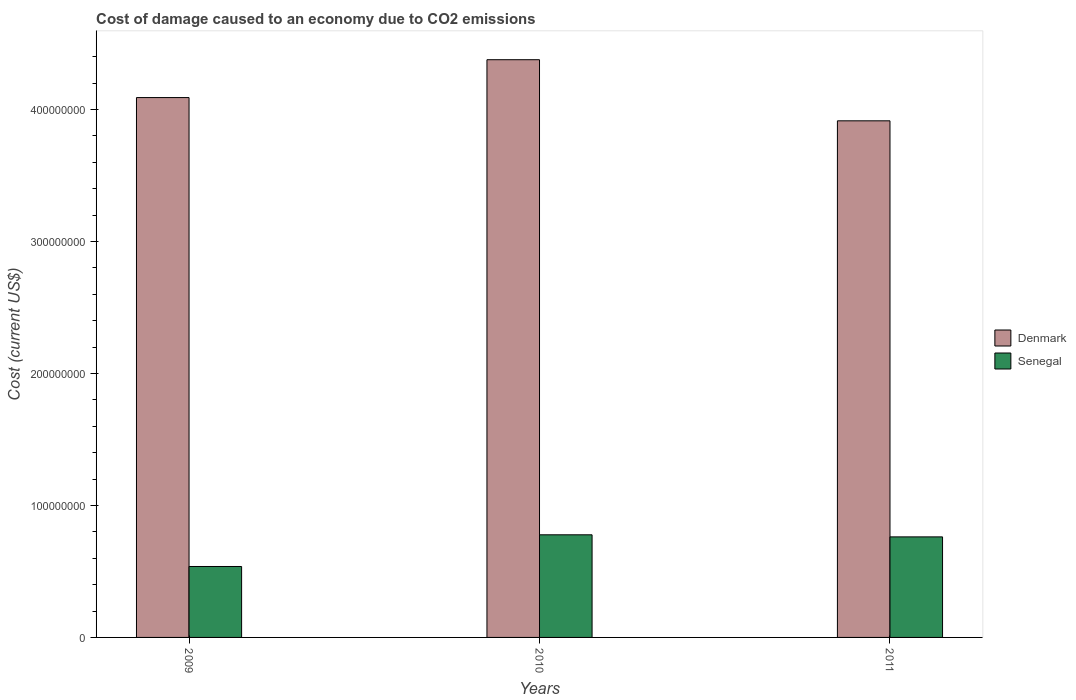How many groups of bars are there?
Your answer should be compact. 3. How many bars are there on the 2nd tick from the left?
Keep it short and to the point. 2. What is the cost of damage caused due to CO2 emissisons in Denmark in 2011?
Ensure brevity in your answer.  3.91e+08. Across all years, what is the maximum cost of damage caused due to CO2 emissisons in Denmark?
Your answer should be compact. 4.38e+08. Across all years, what is the minimum cost of damage caused due to CO2 emissisons in Senegal?
Provide a short and direct response. 5.37e+07. In which year was the cost of damage caused due to CO2 emissisons in Senegal maximum?
Keep it short and to the point. 2010. In which year was the cost of damage caused due to CO2 emissisons in Senegal minimum?
Offer a very short reply. 2009. What is the total cost of damage caused due to CO2 emissisons in Denmark in the graph?
Your answer should be compact. 1.24e+09. What is the difference between the cost of damage caused due to CO2 emissisons in Denmark in 2009 and that in 2011?
Make the answer very short. 1.76e+07. What is the difference between the cost of damage caused due to CO2 emissisons in Denmark in 2010 and the cost of damage caused due to CO2 emissisons in Senegal in 2009?
Ensure brevity in your answer.  3.84e+08. What is the average cost of damage caused due to CO2 emissisons in Denmark per year?
Your answer should be very brief. 4.13e+08. In the year 2011, what is the difference between the cost of damage caused due to CO2 emissisons in Denmark and cost of damage caused due to CO2 emissisons in Senegal?
Make the answer very short. 3.15e+08. What is the ratio of the cost of damage caused due to CO2 emissisons in Denmark in 2009 to that in 2011?
Your answer should be compact. 1.05. What is the difference between the highest and the second highest cost of damage caused due to CO2 emissisons in Senegal?
Keep it short and to the point. 1.58e+06. What is the difference between the highest and the lowest cost of damage caused due to CO2 emissisons in Denmark?
Give a very brief answer. 4.63e+07. What does the 1st bar from the left in 2010 represents?
Offer a very short reply. Denmark. How many bars are there?
Keep it short and to the point. 6. What is the difference between two consecutive major ticks on the Y-axis?
Give a very brief answer. 1.00e+08. Does the graph contain grids?
Your answer should be very brief. No. How many legend labels are there?
Give a very brief answer. 2. What is the title of the graph?
Provide a short and direct response. Cost of damage caused to an economy due to CO2 emissions. Does "Saudi Arabia" appear as one of the legend labels in the graph?
Provide a succinct answer. No. What is the label or title of the X-axis?
Keep it short and to the point. Years. What is the label or title of the Y-axis?
Give a very brief answer. Cost (current US$). What is the Cost (current US$) of Denmark in 2009?
Ensure brevity in your answer.  4.09e+08. What is the Cost (current US$) of Senegal in 2009?
Your answer should be very brief. 5.37e+07. What is the Cost (current US$) in Denmark in 2010?
Your answer should be very brief. 4.38e+08. What is the Cost (current US$) in Senegal in 2010?
Your answer should be compact. 7.77e+07. What is the Cost (current US$) of Denmark in 2011?
Your answer should be very brief. 3.91e+08. What is the Cost (current US$) of Senegal in 2011?
Make the answer very short. 7.62e+07. Across all years, what is the maximum Cost (current US$) in Denmark?
Your response must be concise. 4.38e+08. Across all years, what is the maximum Cost (current US$) in Senegal?
Offer a terse response. 7.77e+07. Across all years, what is the minimum Cost (current US$) in Denmark?
Provide a short and direct response. 3.91e+08. Across all years, what is the minimum Cost (current US$) of Senegal?
Provide a succinct answer. 5.37e+07. What is the total Cost (current US$) in Denmark in the graph?
Provide a succinct answer. 1.24e+09. What is the total Cost (current US$) of Senegal in the graph?
Make the answer very short. 2.08e+08. What is the difference between the Cost (current US$) of Denmark in 2009 and that in 2010?
Your response must be concise. -2.87e+07. What is the difference between the Cost (current US$) of Senegal in 2009 and that in 2010?
Give a very brief answer. -2.40e+07. What is the difference between the Cost (current US$) of Denmark in 2009 and that in 2011?
Ensure brevity in your answer.  1.76e+07. What is the difference between the Cost (current US$) of Senegal in 2009 and that in 2011?
Make the answer very short. -2.24e+07. What is the difference between the Cost (current US$) of Denmark in 2010 and that in 2011?
Provide a short and direct response. 4.63e+07. What is the difference between the Cost (current US$) of Senegal in 2010 and that in 2011?
Ensure brevity in your answer.  1.58e+06. What is the difference between the Cost (current US$) in Denmark in 2009 and the Cost (current US$) in Senegal in 2010?
Offer a very short reply. 3.31e+08. What is the difference between the Cost (current US$) of Denmark in 2009 and the Cost (current US$) of Senegal in 2011?
Offer a terse response. 3.33e+08. What is the difference between the Cost (current US$) of Denmark in 2010 and the Cost (current US$) of Senegal in 2011?
Offer a very short reply. 3.62e+08. What is the average Cost (current US$) of Denmark per year?
Provide a short and direct response. 4.13e+08. What is the average Cost (current US$) of Senegal per year?
Provide a short and direct response. 6.92e+07. In the year 2009, what is the difference between the Cost (current US$) of Denmark and Cost (current US$) of Senegal?
Provide a succinct answer. 3.55e+08. In the year 2010, what is the difference between the Cost (current US$) in Denmark and Cost (current US$) in Senegal?
Make the answer very short. 3.60e+08. In the year 2011, what is the difference between the Cost (current US$) in Denmark and Cost (current US$) in Senegal?
Your response must be concise. 3.15e+08. What is the ratio of the Cost (current US$) of Denmark in 2009 to that in 2010?
Provide a succinct answer. 0.93. What is the ratio of the Cost (current US$) in Senegal in 2009 to that in 2010?
Your answer should be compact. 0.69. What is the ratio of the Cost (current US$) in Denmark in 2009 to that in 2011?
Offer a very short reply. 1.04. What is the ratio of the Cost (current US$) in Senegal in 2009 to that in 2011?
Ensure brevity in your answer.  0.71. What is the ratio of the Cost (current US$) in Denmark in 2010 to that in 2011?
Give a very brief answer. 1.12. What is the ratio of the Cost (current US$) of Senegal in 2010 to that in 2011?
Offer a very short reply. 1.02. What is the difference between the highest and the second highest Cost (current US$) in Denmark?
Provide a short and direct response. 2.87e+07. What is the difference between the highest and the second highest Cost (current US$) of Senegal?
Provide a short and direct response. 1.58e+06. What is the difference between the highest and the lowest Cost (current US$) in Denmark?
Your response must be concise. 4.63e+07. What is the difference between the highest and the lowest Cost (current US$) of Senegal?
Ensure brevity in your answer.  2.40e+07. 